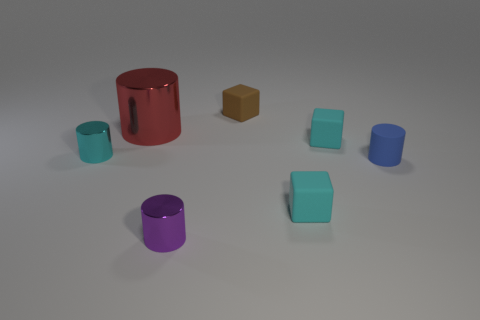Does the rubber cylinder have the same color as the large object?
Give a very brief answer. No. Are there any other things that are the same size as the red object?
Your answer should be compact. No. Is there a purple metallic object?
Offer a very short reply. Yes. What material is the other purple thing that is the same shape as the big thing?
Provide a succinct answer. Metal. There is a tiny blue rubber object that is to the right of the small cyan matte thing behind the tiny shiny object that is on the left side of the big shiny thing; what shape is it?
Provide a short and direct response. Cylinder. What number of cyan matte things are the same shape as the blue matte object?
Offer a very short reply. 0. There is a tiny matte object that is behind the big cylinder; does it have the same color as the small rubber cube in front of the blue cylinder?
Ensure brevity in your answer.  No. There is a blue thing that is the same size as the brown thing; what material is it?
Your answer should be compact. Rubber. Are there any red metallic objects that have the same size as the blue rubber thing?
Your answer should be compact. No. Are there fewer big things to the right of the red metallic thing than tiny objects?
Your answer should be compact. Yes. 